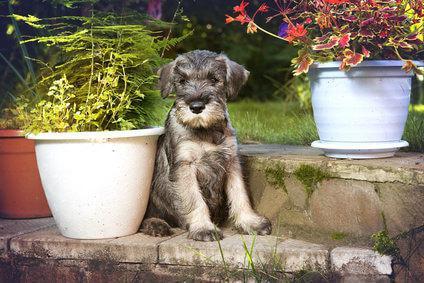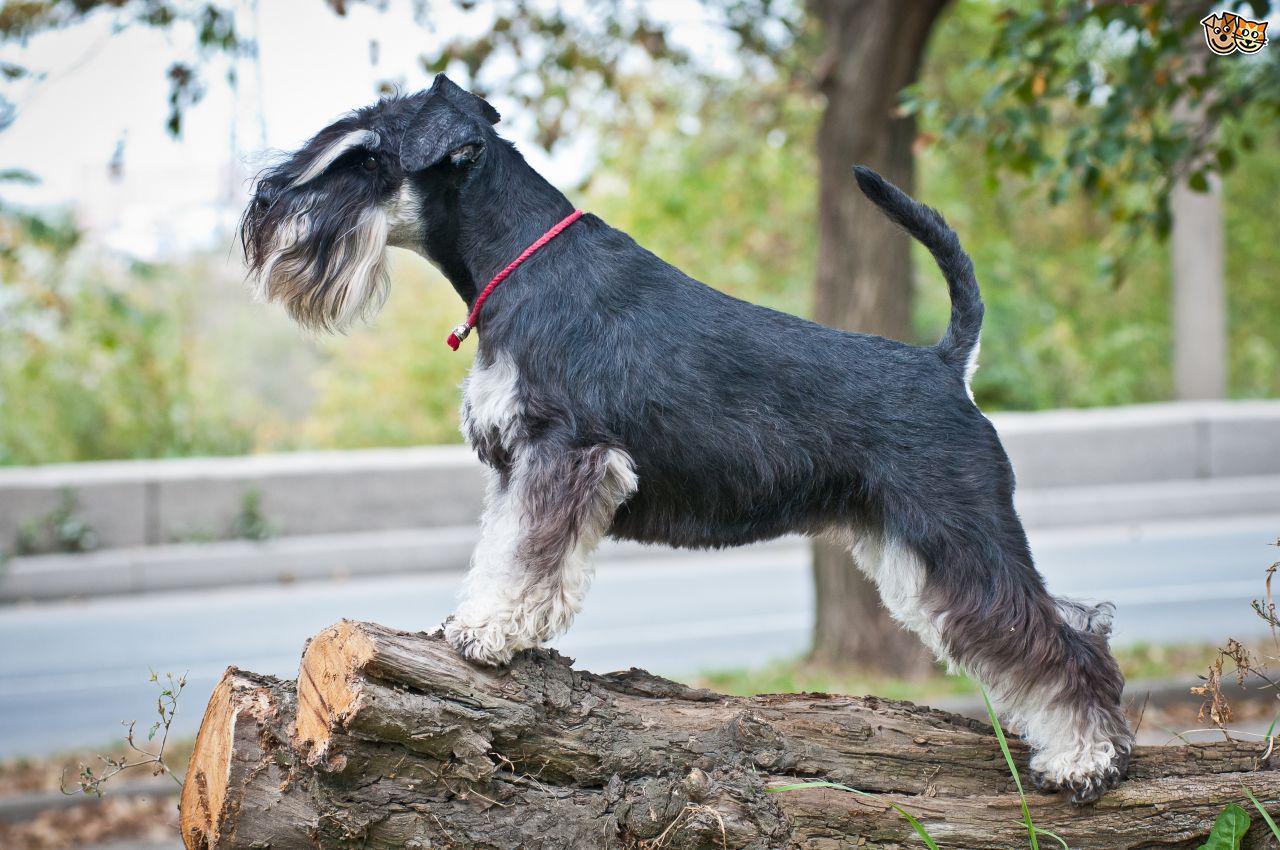The first image is the image on the left, the second image is the image on the right. Evaluate the accuracy of this statement regarding the images: "In one image, a dog standing with legs straight and tail curled up is wearing a red collar.". Is it true? Answer yes or no. Yes. The first image is the image on the left, the second image is the image on the right. For the images displayed, is the sentence "Right image shows a schnauzer in a collar standing facing leftward." factually correct? Answer yes or no. Yes. 